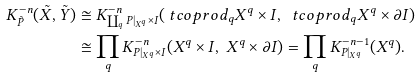<formula> <loc_0><loc_0><loc_500><loc_500>K ^ { - n } _ { \tilde { P } } ( \tilde { X } , \tilde { Y } ) & \cong K ^ { - n } _ { \coprod _ { q } P | _ { X ^ { q } } \times I } ( \ t c o p r o d _ { q } X ^ { q } \times I , \ \ t c o p r o d _ { q } X ^ { q } \times \partial I ) \\ & \cong \prod _ { q } K ^ { - n } _ { P | _ { X ^ { q } } \times I } ( X ^ { q } \times I , \ X ^ { q } \times \partial I ) = \prod _ { q } K ^ { - n - 1 } _ { P | _ { X ^ { q } } } ( X ^ { q } ) .</formula> 